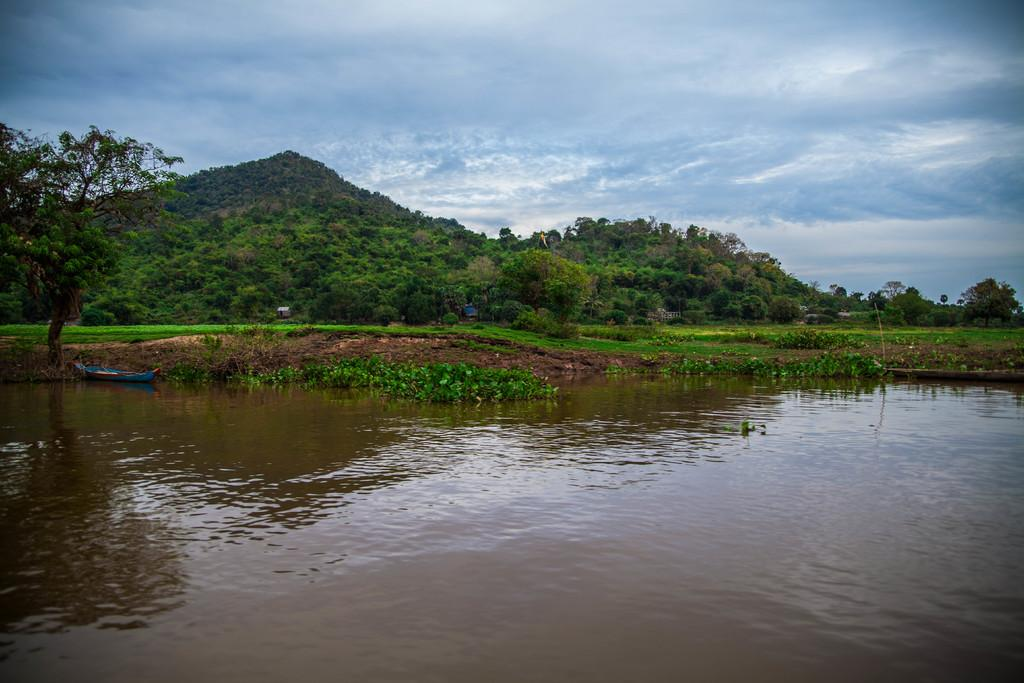What body of water is present in the image? There is a river in the image. What is located beside the river? There is a small boat beside the river. What type of vegetation is present in front of the boat? There is a lot of grass in front of the boat. What other natural elements can be seen in the image? There are many trees in the image. What is the large geographical feature visible behind the trees? There is a big mountain behind the trees. What type of class is being taught in the image? There is no class or teaching activity present in the image. 